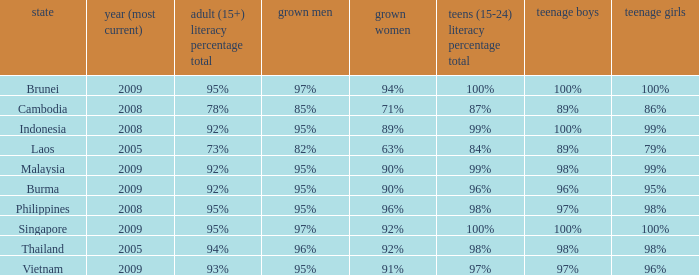Which country has its most recent year as being 2005 and has an Adult Men literacy rate of 96%? Thailand. 